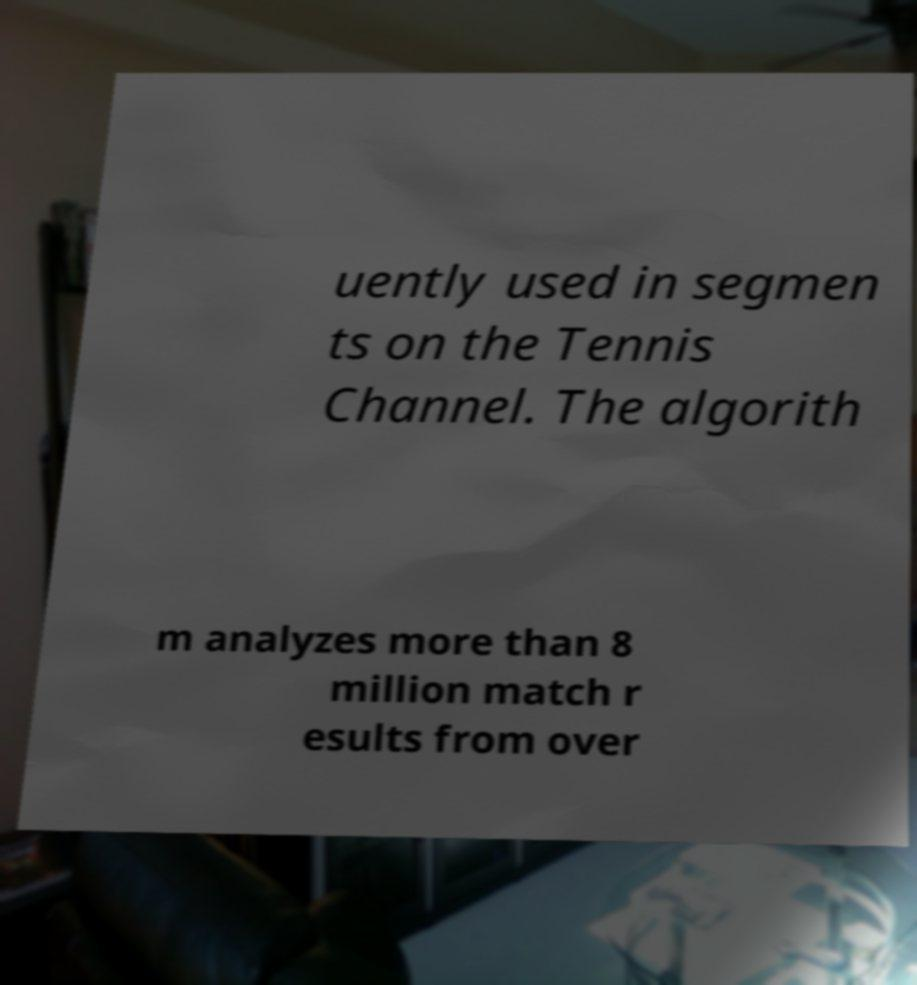Can you read and provide the text displayed in the image?This photo seems to have some interesting text. Can you extract and type it out for me? uently used in segmen ts on the Tennis Channel. The algorith m analyzes more than 8 million match r esults from over 